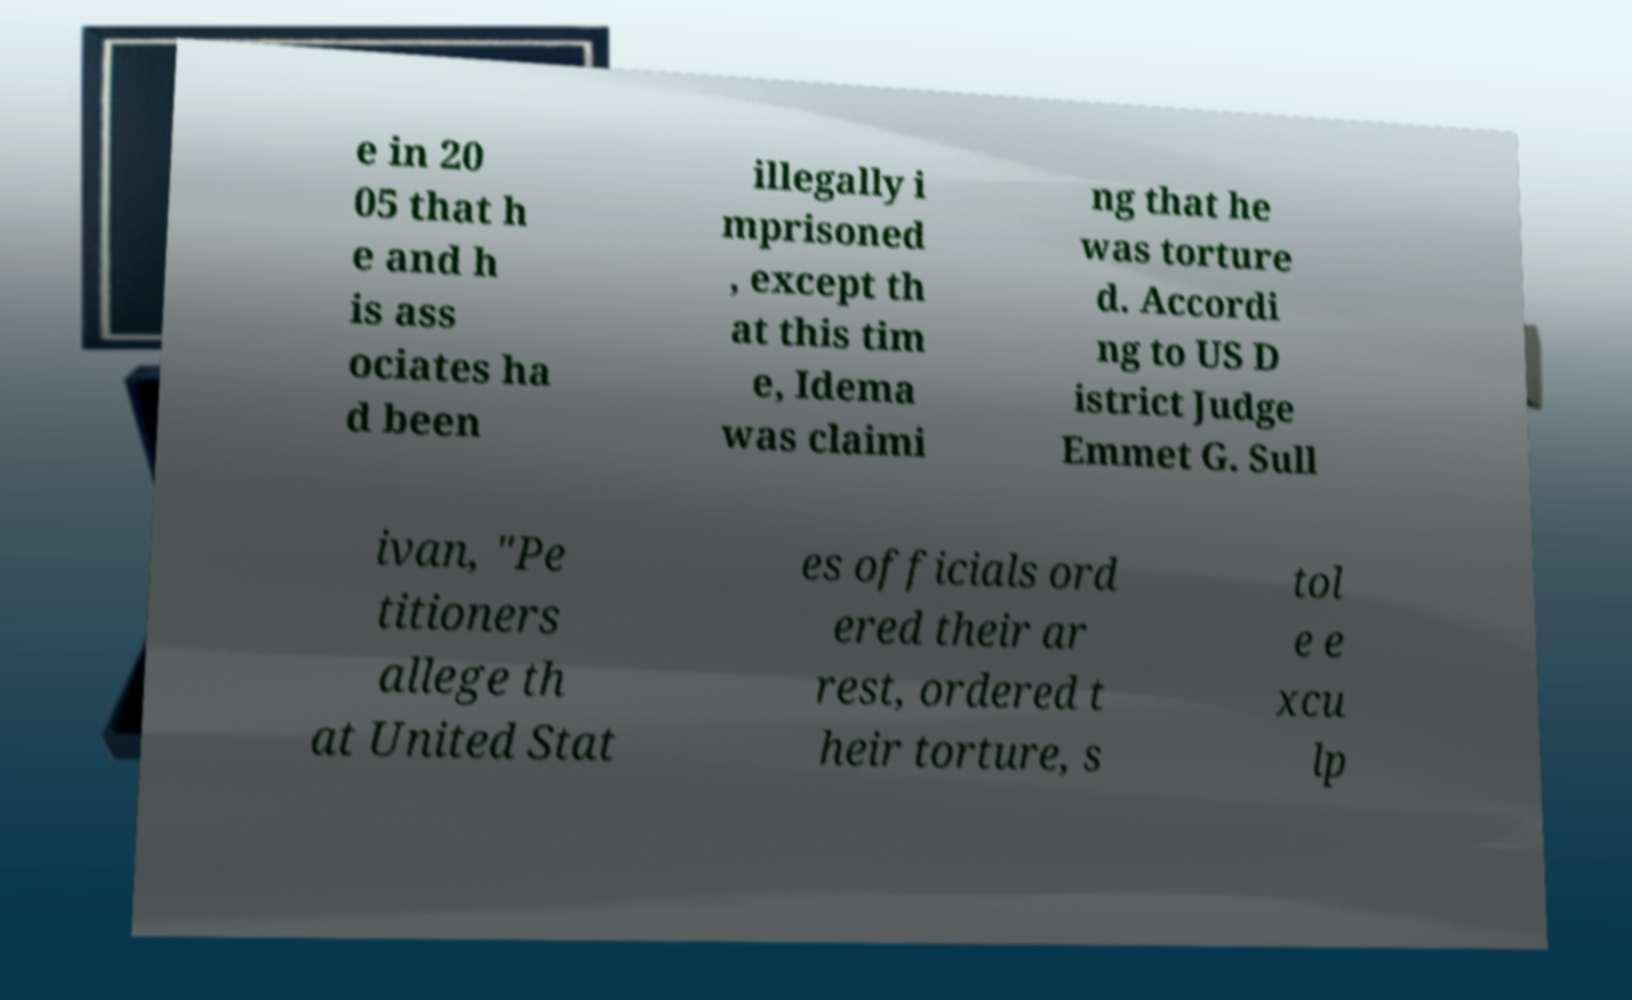What messages or text are displayed in this image? I need them in a readable, typed format. e in 20 05 that h e and h is ass ociates ha d been illegally i mprisoned , except th at this tim e, Idema was claimi ng that he was torture d. Accordi ng to US D istrict Judge Emmet G. Sull ivan, "Pe titioners allege th at United Stat es officials ord ered their ar rest, ordered t heir torture, s tol e e xcu lp 